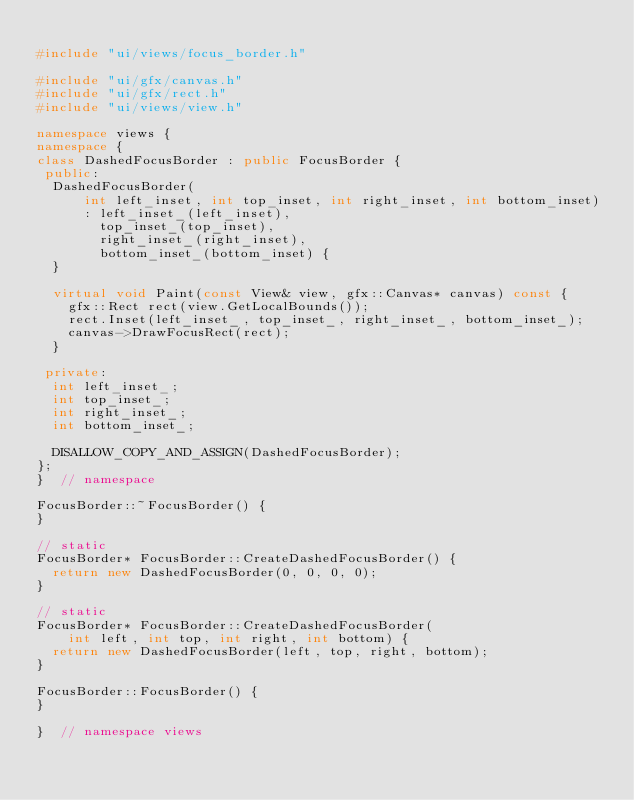<code> <loc_0><loc_0><loc_500><loc_500><_C++_>
#include "ui/views/focus_border.h"

#include "ui/gfx/canvas.h"
#include "ui/gfx/rect.h"
#include "ui/views/view.h"

namespace views {
namespace {
class DashedFocusBorder : public FocusBorder {
 public:
  DashedFocusBorder(
      int left_inset, int top_inset, int right_inset, int bottom_inset)
      : left_inset_(left_inset),
        top_inset_(top_inset),
        right_inset_(right_inset),
        bottom_inset_(bottom_inset) {
  }

  virtual void Paint(const View& view, gfx::Canvas* canvas) const {
    gfx::Rect rect(view.GetLocalBounds());
    rect.Inset(left_inset_, top_inset_, right_inset_, bottom_inset_);
    canvas->DrawFocusRect(rect);
  }

 private:
  int left_inset_;
  int top_inset_;
  int right_inset_;
  int bottom_inset_;

  DISALLOW_COPY_AND_ASSIGN(DashedFocusBorder);
};
}  // namespace

FocusBorder::~FocusBorder() {
}

// static
FocusBorder* FocusBorder::CreateDashedFocusBorder() {
  return new DashedFocusBorder(0, 0, 0, 0);
}

// static
FocusBorder* FocusBorder::CreateDashedFocusBorder(
    int left, int top, int right, int bottom) {
  return new DashedFocusBorder(left, top, right, bottom);
}

FocusBorder::FocusBorder() {
}

}  // namespace views
</code> 